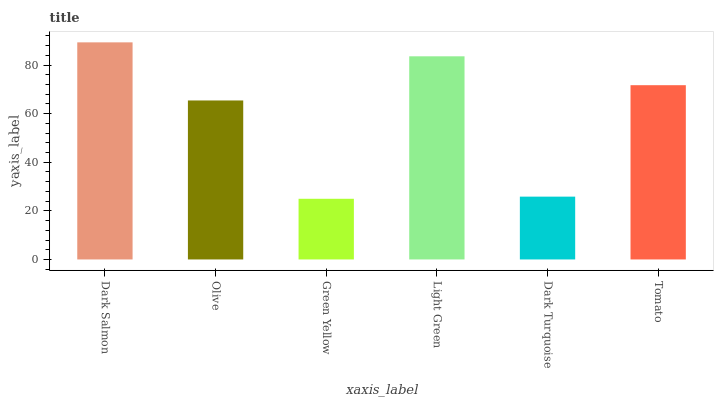Is Olive the minimum?
Answer yes or no. No. Is Olive the maximum?
Answer yes or no. No. Is Dark Salmon greater than Olive?
Answer yes or no. Yes. Is Olive less than Dark Salmon?
Answer yes or no. Yes. Is Olive greater than Dark Salmon?
Answer yes or no. No. Is Dark Salmon less than Olive?
Answer yes or no. No. Is Tomato the high median?
Answer yes or no. Yes. Is Olive the low median?
Answer yes or no. Yes. Is Dark Salmon the high median?
Answer yes or no. No. Is Green Yellow the low median?
Answer yes or no. No. 